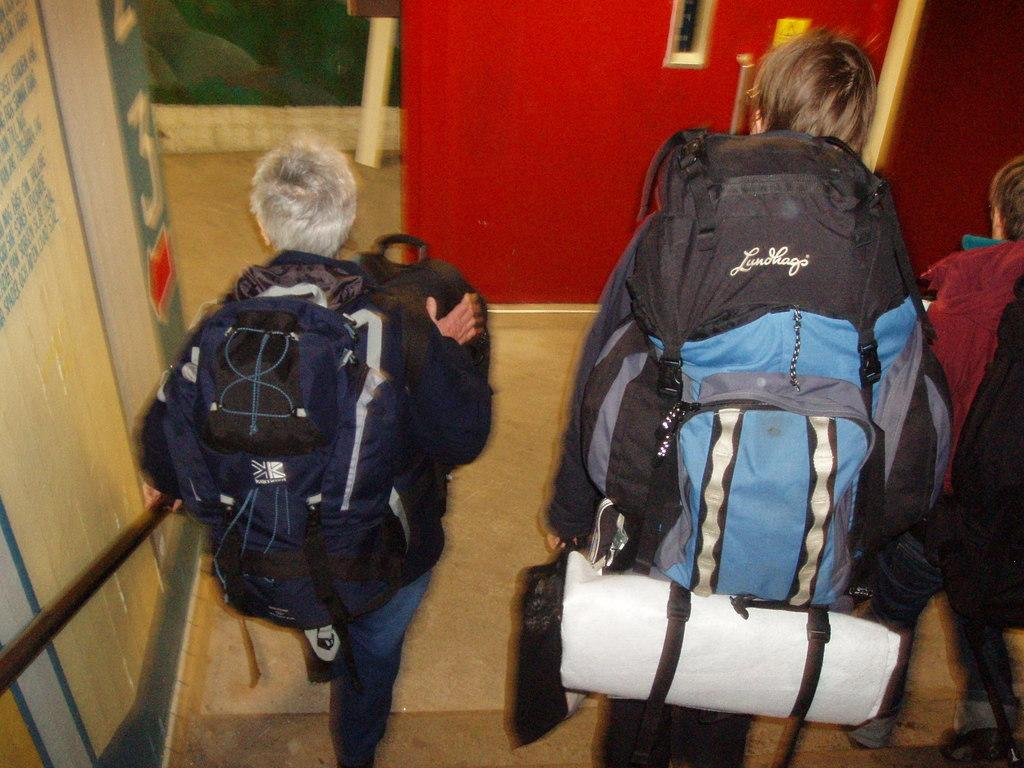How many people are in the image? There are three persons in the image. What are the three persons holding in their hands? Each of the three persons is holding a bag in their hand. What are the three persons doing in the image? The three persons are walking. What type of ant can be seen carrying a flag in the image? There are no ants or flags present in the image. What event is taking place in the image? The provided facts do not mention any specific event taking place in the image. 